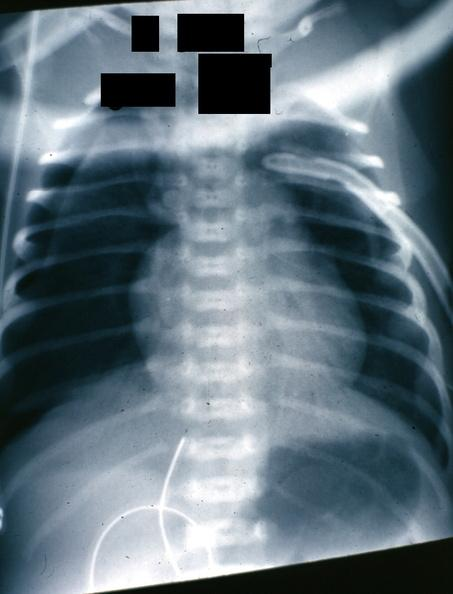does this image show x-ray nicely shown pneumothorax in infant?
Answer the question using a single word or phrase. Yes 